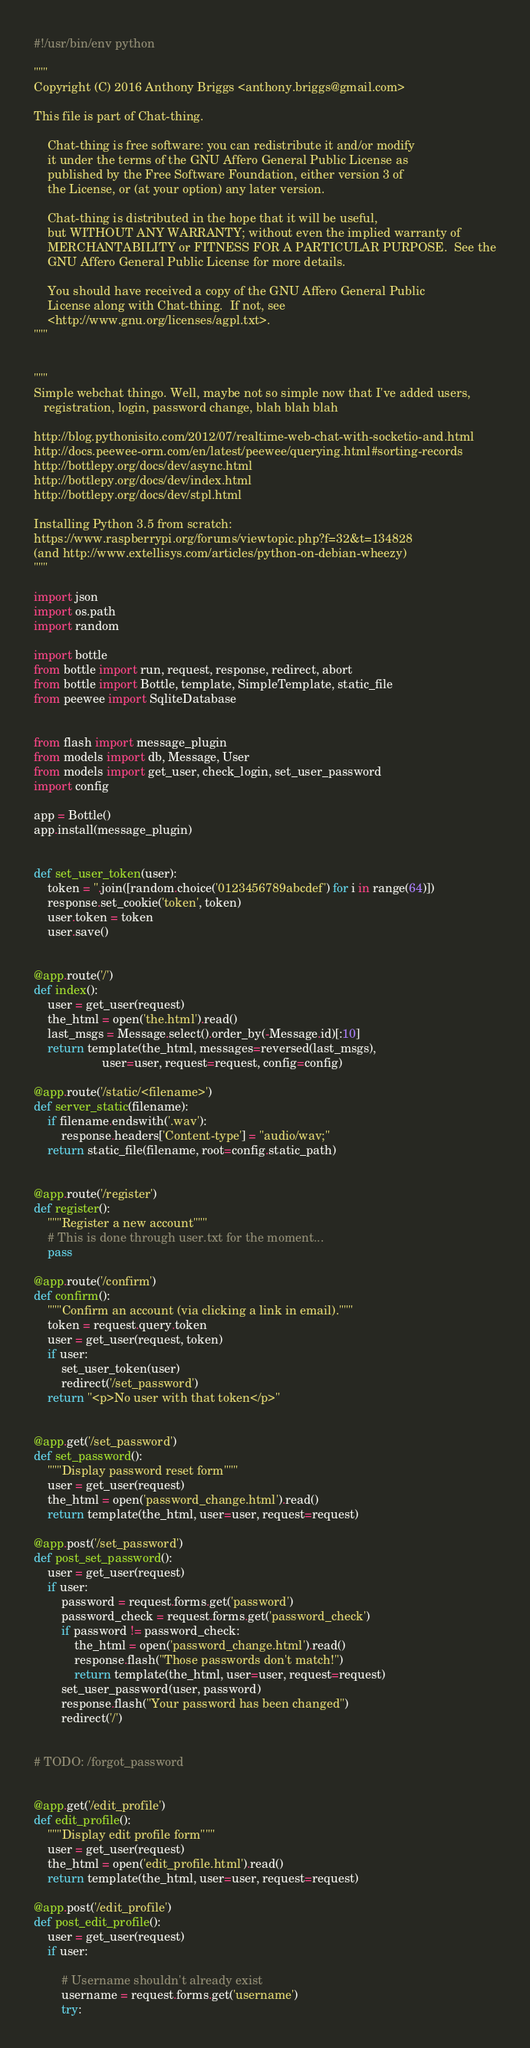Convert code to text. <code><loc_0><loc_0><loc_500><loc_500><_Python_>#!/usr/bin/env python

"""
Copyright (C) 2016 Anthony Briggs <anthony.briggs@gmail.com>

This file is part of Chat-thing.

    Chat-thing is free software: you can redistribute it and/or modify
    it under the terms of the GNU Affero General Public License as 
    published by the Free Software Foundation, either version 3 of 
    the License, or (at your option) any later version.

    Chat-thing is distributed in the hope that it will be useful,
    but WITHOUT ANY WARRANTY; without even the implied warranty of
    MERCHANTABILITY or FITNESS FOR A PARTICULAR PURPOSE.  See the
    GNU Affero General Public License for more details.

    You should have received a copy of the GNU Affero General Public 
    License along with Chat-thing.  If not, see 
    <http://www.gnu.org/licenses/agpl.txt>.
"""


"""
Simple webchat thingo. Well, maybe not so simple now that I've added users,
   registration, login, password change, blah blah blah

http://blog.pythonisito.com/2012/07/realtime-web-chat-with-socketio-and.html
http://docs.peewee-orm.com/en/latest/peewee/querying.html#sorting-records
http://bottlepy.org/docs/dev/async.html
http://bottlepy.org/docs/dev/index.html
http://bottlepy.org/docs/dev/stpl.html

Installing Python 3.5 from scratch:
https://www.raspberrypi.org/forums/viewtopic.php?f=32&t=134828
(and http://www.extellisys.com/articles/python-on-debian-wheezy)
"""

import json
import os.path
import random

import bottle
from bottle import run, request, response, redirect, abort
from bottle import Bottle, template, SimpleTemplate, static_file
from peewee import SqliteDatabase


from flash import message_plugin
from models import db, Message, User
from models import get_user, check_login, set_user_password
import config

app = Bottle()
app.install(message_plugin)


def set_user_token(user):
    token = ''.join([random.choice('0123456789abcdef') for i in range(64)])
    response.set_cookie('token', token)
    user.token = token
    user.save()


@app.route('/')
def index():
    user = get_user(request)
    the_html = open('the.html').read()
    last_msgs = Message.select().order_by(-Message.id)[:10]
    return template(the_html, messages=reversed(last_msgs), 
                    user=user, request=request, config=config)

@app.route('/static/<filename>')
def server_static(filename):
    if filename.endswith('.wav'):
        response.headers['Content-type'] = "audio/wav;"
    return static_file(filename, root=config.static_path)


@app.route('/register')
def register():
    """Register a new account"""
    # This is done through user.txt for the moment...
    pass

@app.route('/confirm')
def confirm():
    """Confirm an account (via clicking a link in email)."""
    token = request.query.token
    user = get_user(request, token)
    if user:
        set_user_token(user)
        redirect('/set_password')
    return "<p>No user with that token</p>"


@app.get('/set_password')
def set_password():
    """Display password reset form"""
    user = get_user(request)
    the_html = open('password_change.html').read()
    return template(the_html, user=user, request=request)

@app.post('/set_password')
def post_set_password():
    user = get_user(request)
    if user:
        password = request.forms.get('password')
        password_check = request.forms.get('password_check')
        if password != password_check:
            the_html = open('password_change.html').read()
            response.flash("Those passwords don't match!")
            return template(the_html, user=user, request=request)
        set_user_password(user, password)
        response.flash("Your password has been changed")
        redirect('/')


# TODO: /forgot_password


@app.get('/edit_profile')
def edit_profile():
    """Display edit profile form"""
    user = get_user(request)
    the_html = open('edit_profile.html').read()
    return template(the_html, user=user, request=request)

@app.post('/edit_profile')
def post_edit_profile():
    user = get_user(request)
    if user:
        
        # Username shouldn't already exist
        username = request.forms.get('username')
        try:</code> 